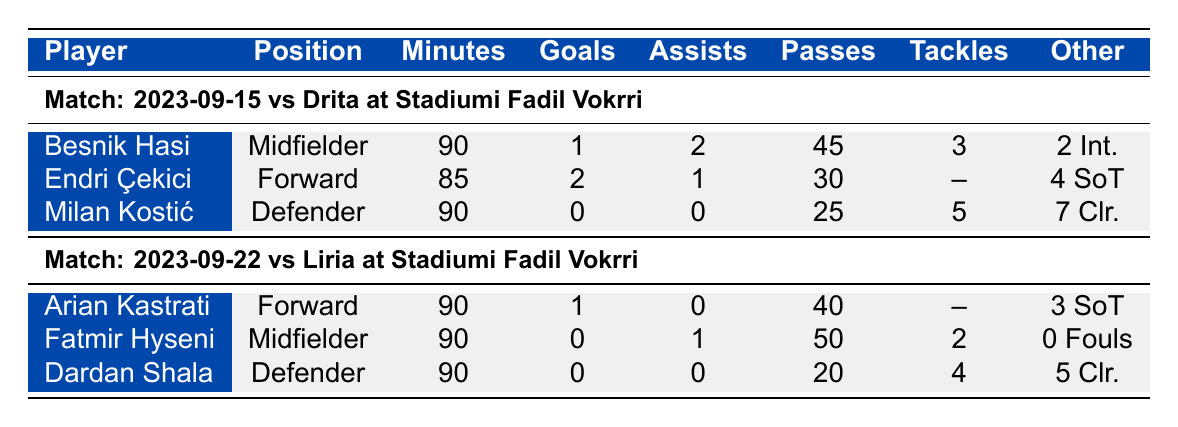What is the total number of goals scored by Ballkani players in the match against Drita? In the match against Drita, the goals were scored by Endri Çekici (2 goals) and Besnik Hasi (1 goal). Summing these gives a total of 2 + 1 = 3 goals.
Answer: 3 Who played the most minutes in the match against Liria? In the match against Liria, both Arian Kastrati and Fatmir Hyseni played 90 minutes. Since they both played the maximum minutes, we identify them as the players who played the most.
Answer: Arian Kastrati and Fatmir Hyseni Did Milan Kostić contribute to any goals in the match against Drita? Milan Kostić did not score any goals and also did not provide any assists in the match against Drita, confirming that he did not contribute to any goals.
Answer: No What is the average number of tackles made by defenders in both matches? In the match against Drita, Milan Kostić made 5 tackles, and in the match against Liria, Dardan Shala made 4 tackles. The average is calculated as (5 + 4) / 2 = 4.5.
Answer: 4.5 Which player has the highest number of assists across both matches? Besnik Hasi has 2 assists in the match against Drita, and Fatmir Hyseni has 1 assist in the match against Liria. Since 2 is higher than 1, Besnik Hasi has the highest number of assists across both matches.
Answer: Besnik Hasi How many shots on target did Endri Çekici have in the match against Drita? The table shows that Endri Çekici had 4 shots on target in the match against Drita.
Answer: 4 Was Arian Kastrati the only forward player who scored in the matches listed? In the match against Drita, only Endri Çekici scored, and in the match against Liria, Arian Kastrati scored. This indicates that Arian Kastrati was not the only forward to score across the two matches, as Endri did score too.
Answer: No What is the total number of completed passes by players in the match against Liria? Arian Kastrati completed 40 passes, Fatmir Hyseni completed 50 passes, and Dardan Shala completed 20 passes. Summing these gives 40 + 50 + 20 = 110 completed passes in total.
Answer: 110 